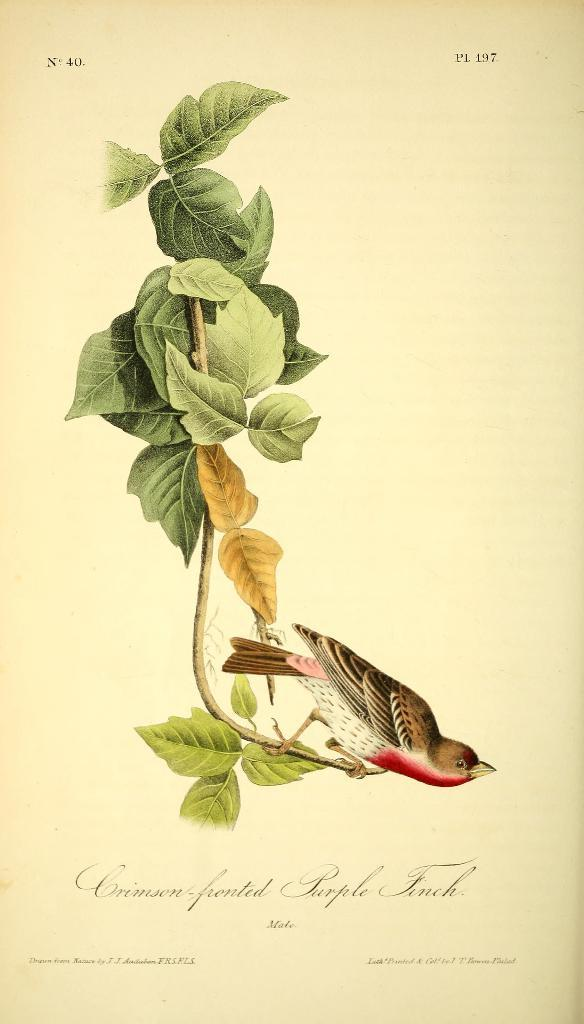What type of visual is depicted in the image? The image is a poster. What animal can be seen in the image? There is a bird in the image. Where is the bird located in the image? The bird is on the branch of a tree. Are there any words or phrases on the image? Yes, there is text on the image. What color is the sweater worn by the bird in the image? There is no sweater worn by the bird in the image, as it is a bird and not a person. 